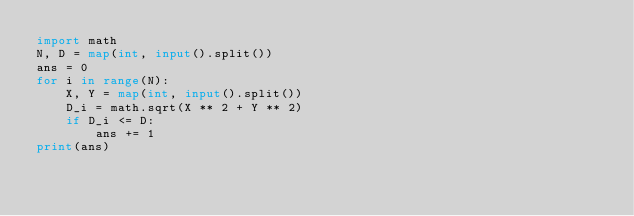<code> <loc_0><loc_0><loc_500><loc_500><_Python_>import math
N, D = map(int, input().split())
ans = 0
for i in range(N):
    X, Y = map(int, input().split())
    D_i = math.sqrt(X ** 2 + Y ** 2)
    if D_i <= D:
        ans += 1
print(ans)</code> 